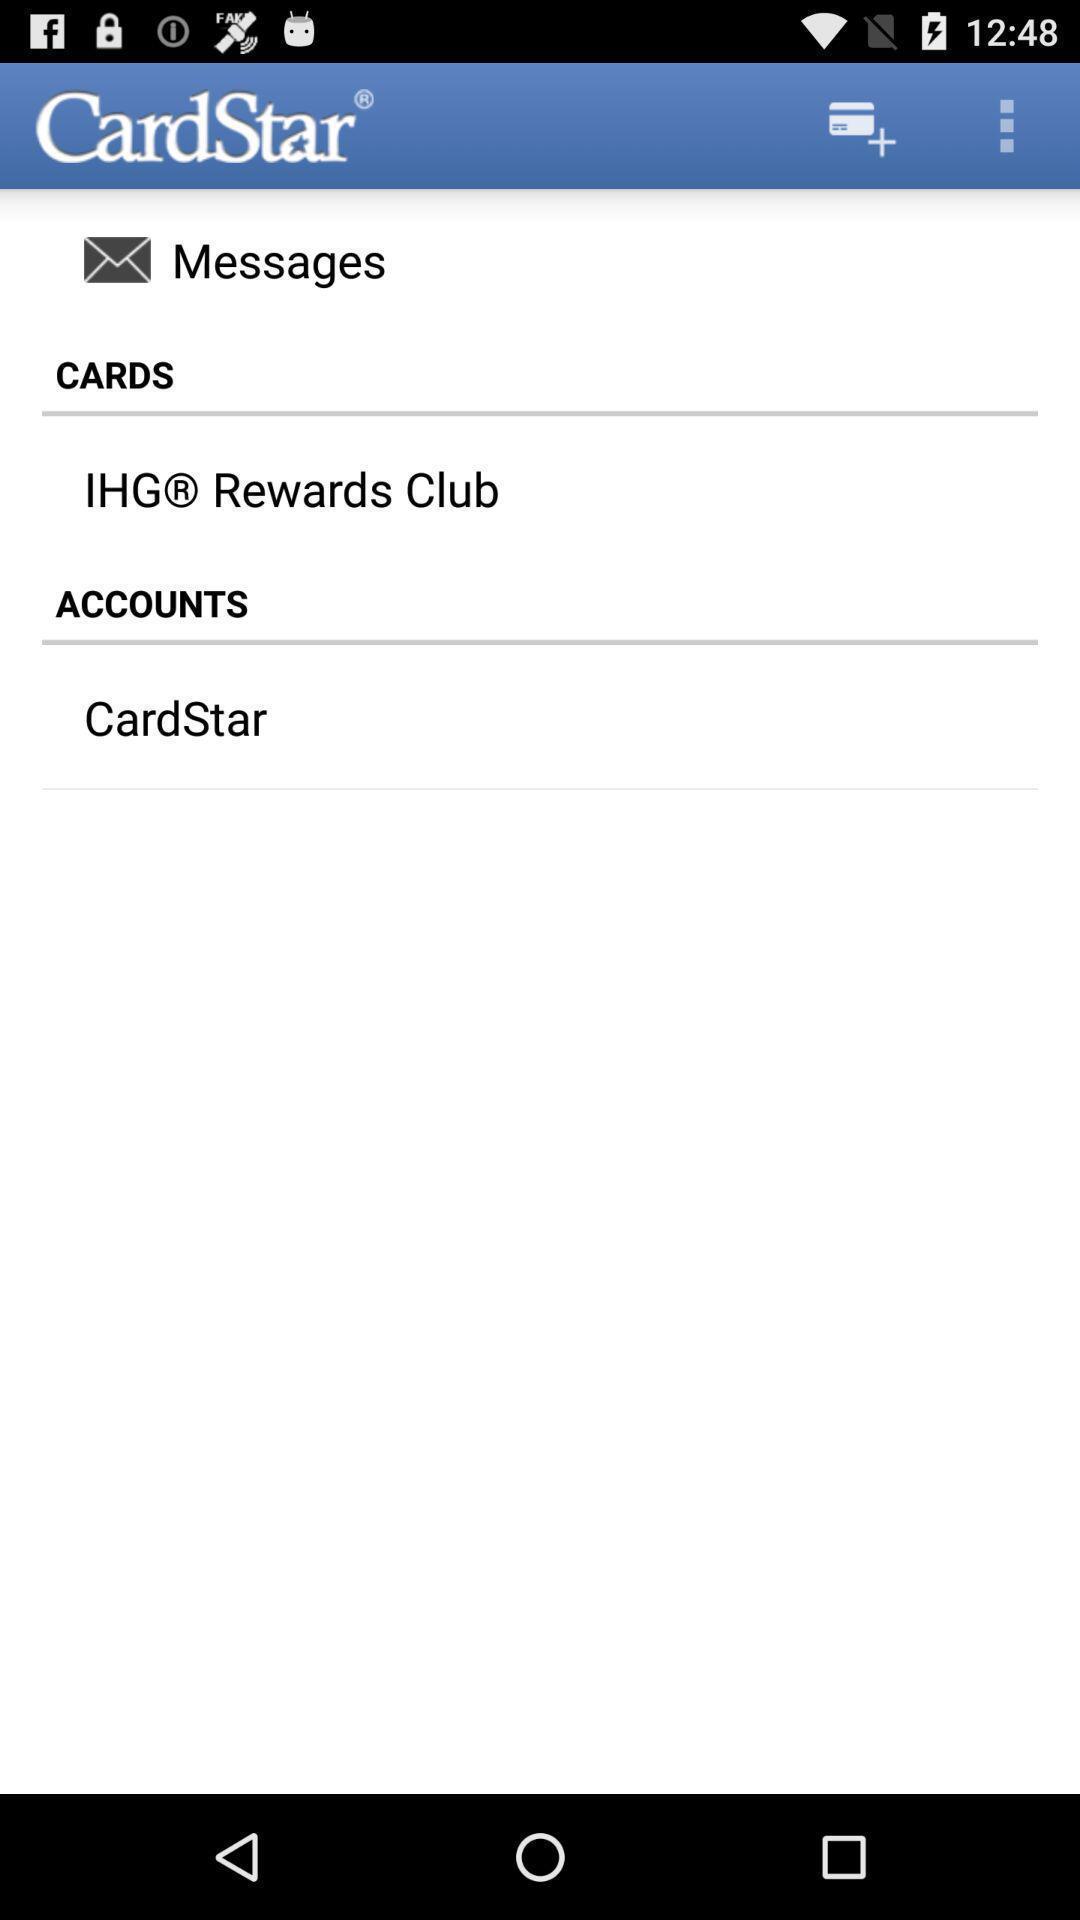What is the overall content of this screenshot? Screen displaying the messages and rewards folder. 